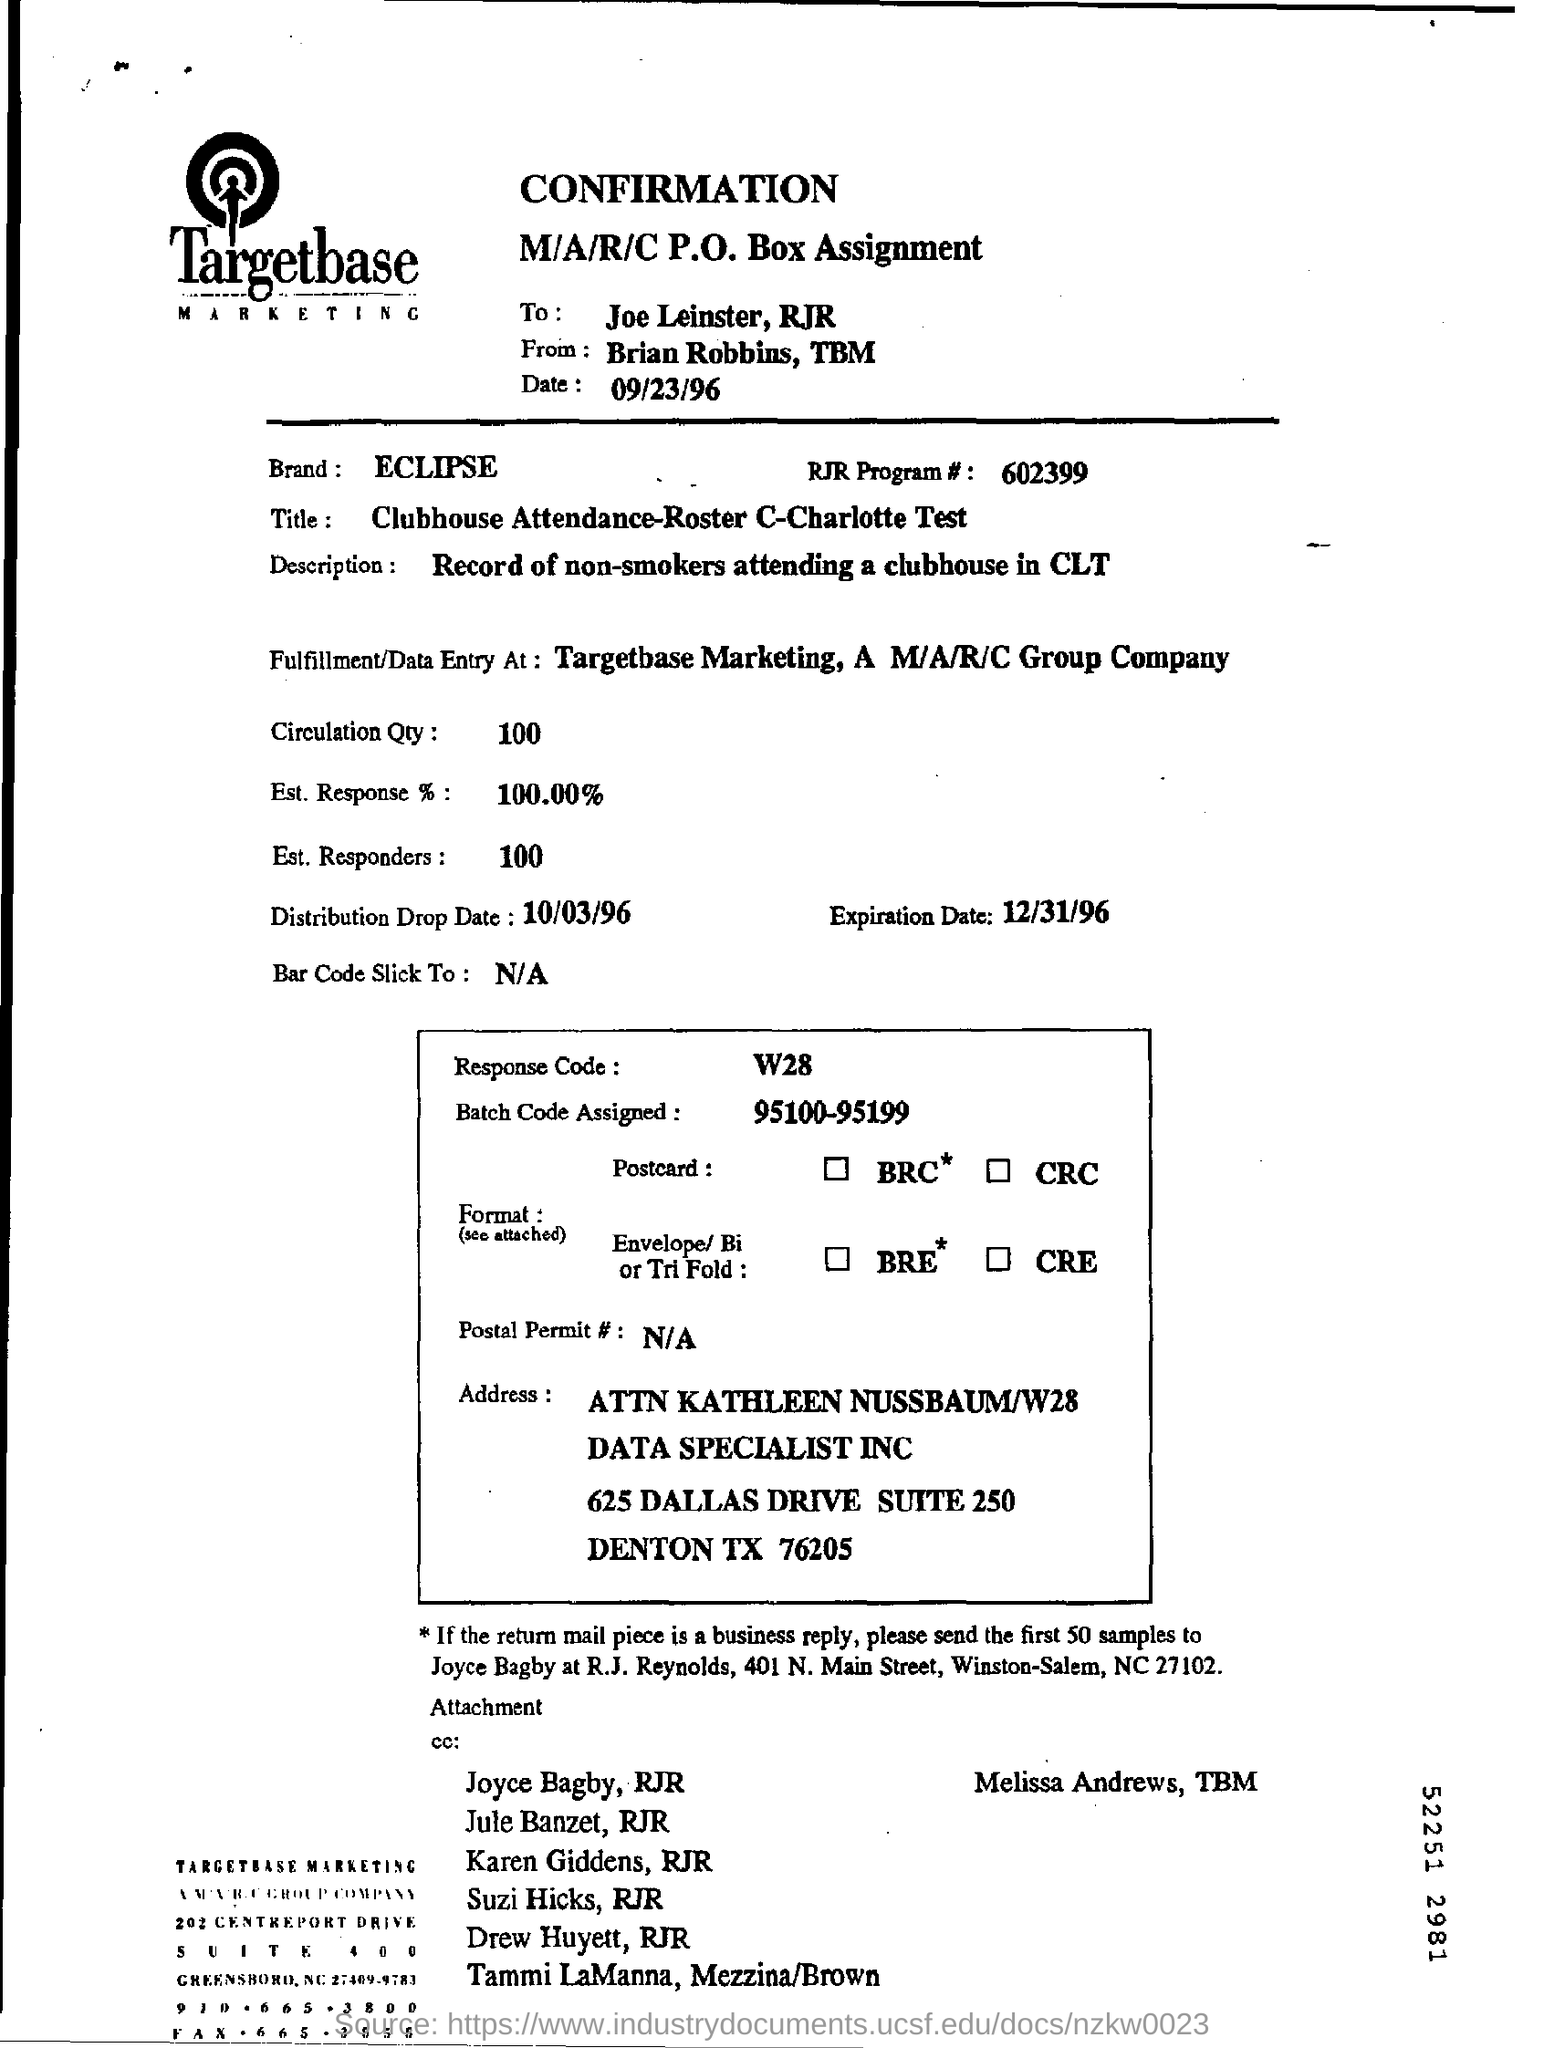Give some essential details in this illustration. The brand name is Eclipse. Targetbase is the name of the marketing company. The heading of the document is CONFIRMATION. The expiration date mentioned is December 31, 1996. 